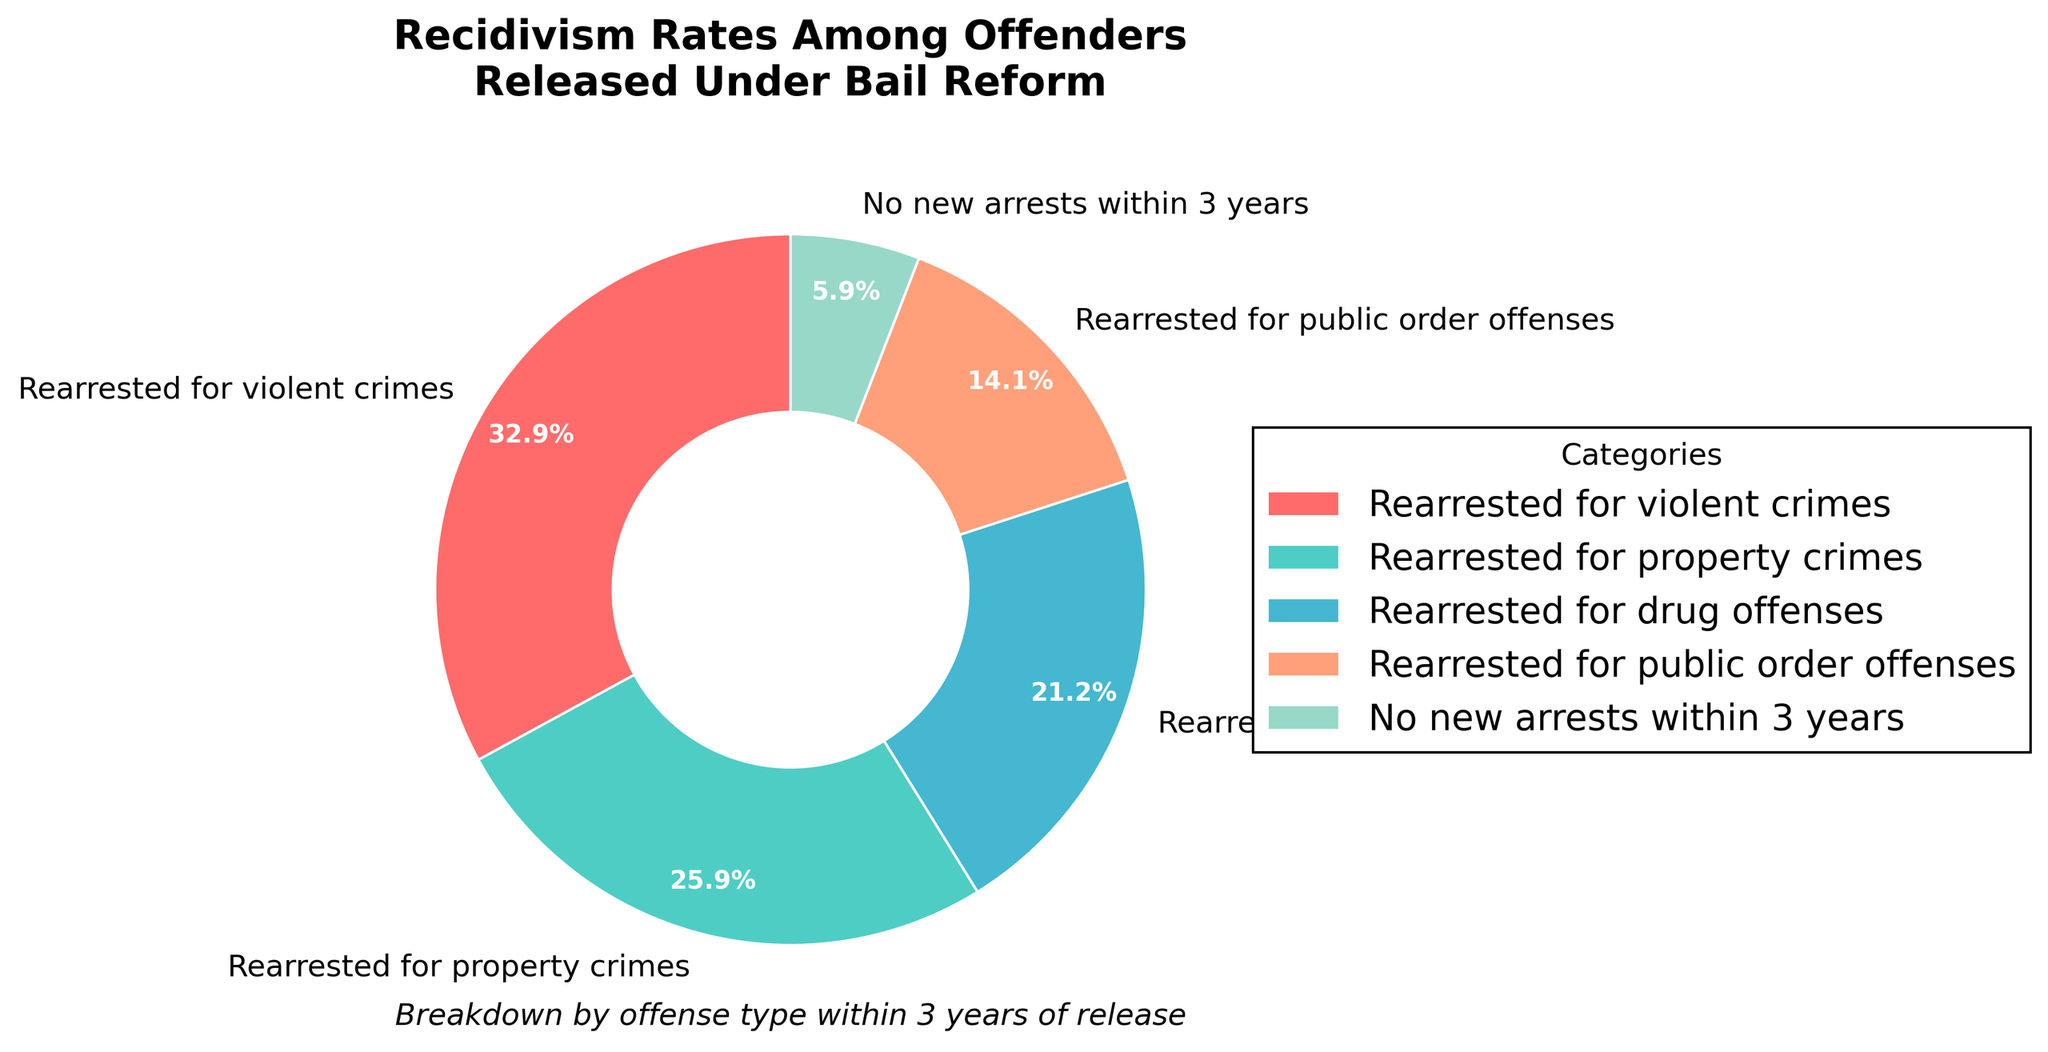What's the largest category of rearrest under bail reform? The category with the highest percentage in the pie chart represents the largest group of rearrest. By observing the chart, "Rearrested for violent crimes" has the largest slice.
Answer: Rearrested for violent crimes How many times more likely are offenders to be rearrested for violent crimes compared to those with no new arrests? Observing the percentages, 28% of offenders are rearrested for violent crimes while 5% have no new arrests. Dividing 28 by 5 gives the factor of likelihood. 28/5 = 5.6
Answer: 5.6 times What is the sum of the percentages for offenders rearrested for property-related and drug offenses? Rearrested for property crimes constitutes 22% and drug offenses 18%. Add these percentages together: 22 + 18 = 40%
Answer: 40% Which category has the smallest percentage? Identifying the smallest slice in the pie chart, "No new arrests within 3 years" has the smallest percentage.
Answer: No new arrests within 3 years Are offenders more often rearrested for public order offenses than for drug offenses? Compare the slices for public order offenses (12%) and drug offenses (18%) in the pie chart. Public order offenses have a smaller percentage than drug offenses.
Answer: No What's the difference between the percentage of those rearrested for violent crimes and those for property crimes? Subtract the percentage of property crimes (22%) from violent crimes (28%), giving 28 - 22 = 6%.
Answer: 6% Which categories combined make up more than half of the total rearrests? Adding the percentages of the top categories until the sum exceeds 50%. Violent crimes (28%) + Property crimes (22%) = 50%. Adding Drug offenses (18%) gives 68%, which is more than half.
Answer: Violent crimes, Property crimes, Drug offenses What percentage of offenders are rearrested for either drug or public order offenses? Sum the percentages for drug offenses (18%) and public order offenses (12%). 18 + 12 = 30%.
Answer: 30% Which slice in the pie chart is colored red? Observing the color scheme used in the chart, the red slice (color closest to red in a typical palette) represents "Rearrested for violent crimes".
Answer: Rearrested for violent crimes 